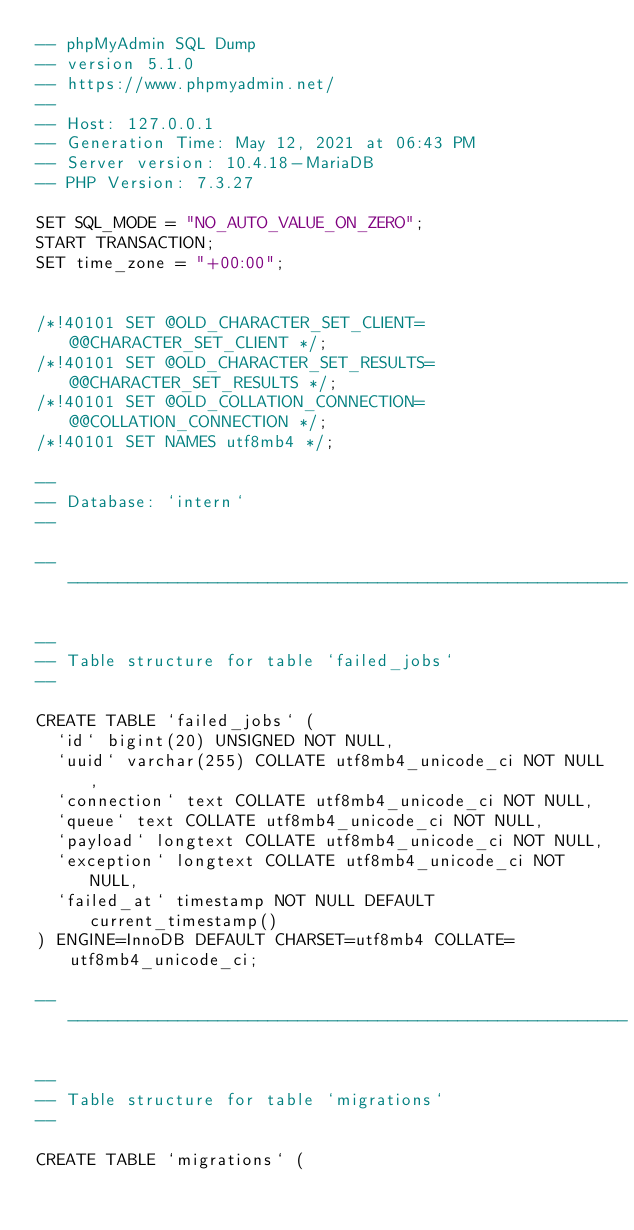Convert code to text. <code><loc_0><loc_0><loc_500><loc_500><_SQL_>-- phpMyAdmin SQL Dump
-- version 5.1.0
-- https://www.phpmyadmin.net/
--
-- Host: 127.0.0.1
-- Generation Time: May 12, 2021 at 06:43 PM
-- Server version: 10.4.18-MariaDB
-- PHP Version: 7.3.27

SET SQL_MODE = "NO_AUTO_VALUE_ON_ZERO";
START TRANSACTION;
SET time_zone = "+00:00";


/*!40101 SET @OLD_CHARACTER_SET_CLIENT=@@CHARACTER_SET_CLIENT */;
/*!40101 SET @OLD_CHARACTER_SET_RESULTS=@@CHARACTER_SET_RESULTS */;
/*!40101 SET @OLD_COLLATION_CONNECTION=@@COLLATION_CONNECTION */;
/*!40101 SET NAMES utf8mb4 */;

--
-- Database: `intern`
--

-- --------------------------------------------------------

--
-- Table structure for table `failed_jobs`
--

CREATE TABLE `failed_jobs` (
  `id` bigint(20) UNSIGNED NOT NULL,
  `uuid` varchar(255) COLLATE utf8mb4_unicode_ci NOT NULL,
  `connection` text COLLATE utf8mb4_unicode_ci NOT NULL,
  `queue` text COLLATE utf8mb4_unicode_ci NOT NULL,
  `payload` longtext COLLATE utf8mb4_unicode_ci NOT NULL,
  `exception` longtext COLLATE utf8mb4_unicode_ci NOT NULL,
  `failed_at` timestamp NOT NULL DEFAULT current_timestamp()
) ENGINE=InnoDB DEFAULT CHARSET=utf8mb4 COLLATE=utf8mb4_unicode_ci;

-- --------------------------------------------------------

--
-- Table structure for table `migrations`
--

CREATE TABLE `migrations` (</code> 